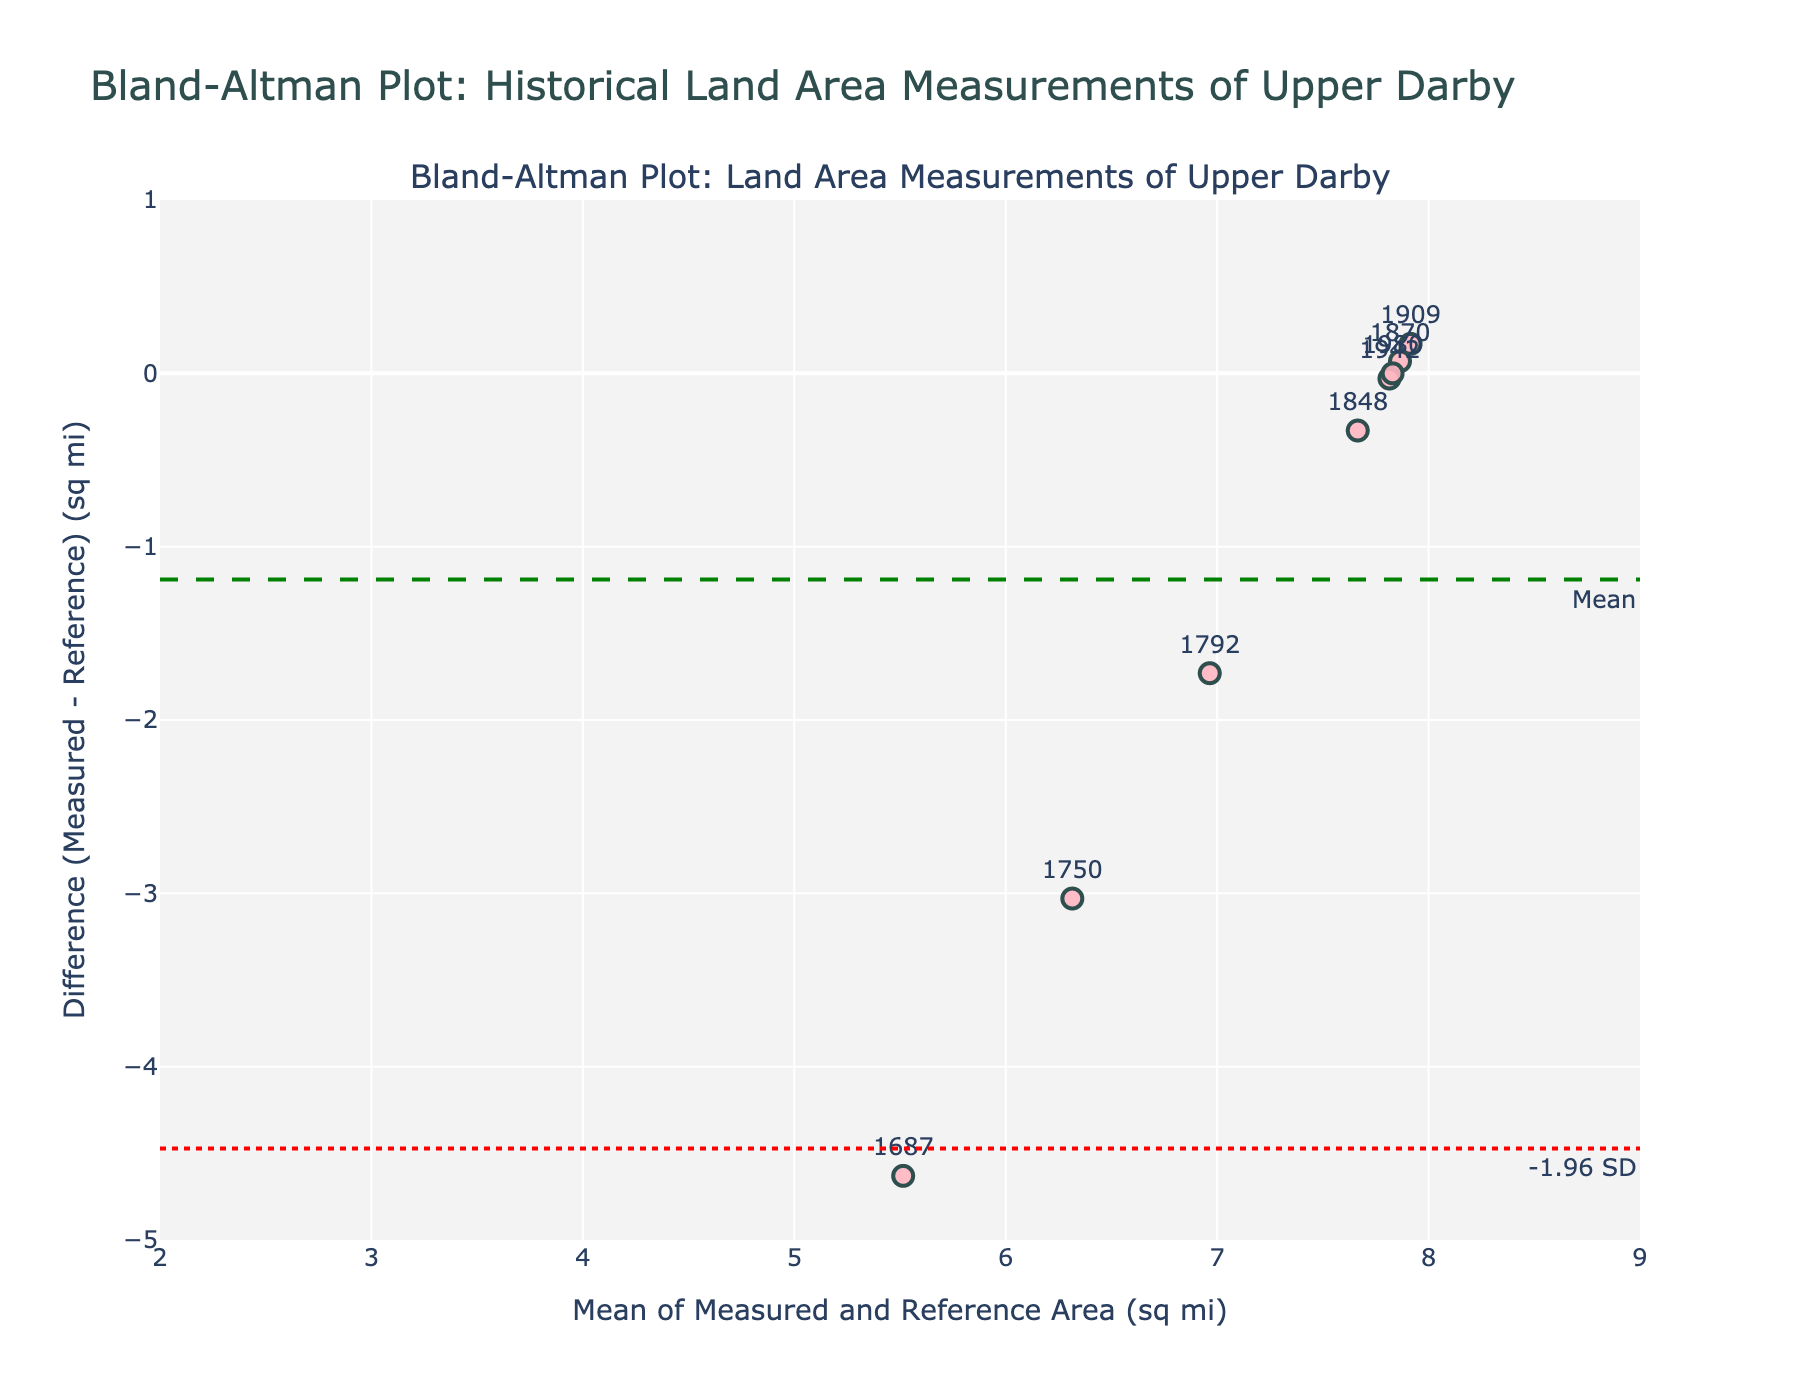What is the title of the figure? The title of the figure is written at the top and reads "Bland-Altman Plot: Historical Land Area Measurements of Upper Darby".
Answer: Bland-Altman Plot: Historical Land Area Measurements of Upper Darby How many historical maps of Upper Darby are represented in the plot? Each data point represents a historical map, and there are 8 data points labeled by year.
Answer: 8 What is the mean difference in the plot? The mean difference is indicated by the green dashed line and labeled "Mean".
Answer: Close to 0 What are the limits of agreement (LoA) in the plot? The limits of agreement are shown as red dotted lines and are labeled "+1.96 SD" and "-1.96 SD".
Answer: -2.86 and 2.86 Which year had the largest deviation from the reference area? The year with the largest deviation is the one with the point farthest from the mean difference line. According to the plot, this is 1687.
Answer: 1687 What is the difference in area for the map from the year 1750? The point labeled "1750" shows the position on the y-axis, which represents the difference. The approximate difference is about -3.0 sq mi.
Answer: -3.0 sq mi For the map year 1980, is the area measurement greater than or less than the reference area? The point for 1980 lies on the mean difference line, indicating that the measured area equals the reference area.
Answer: Equal What is the pattern of the data points in relation to the mean difference? Most of the historical measurements tend to deviate from the reference area in earlier years, converging towards zero difference in more recent years.
Answer: Convergence over time Which map year had a measured area closest to the reference area but not equal? We look for the point closest to the mean difference line but not on it, which appears to be the year 1942.
Answer: 1942 